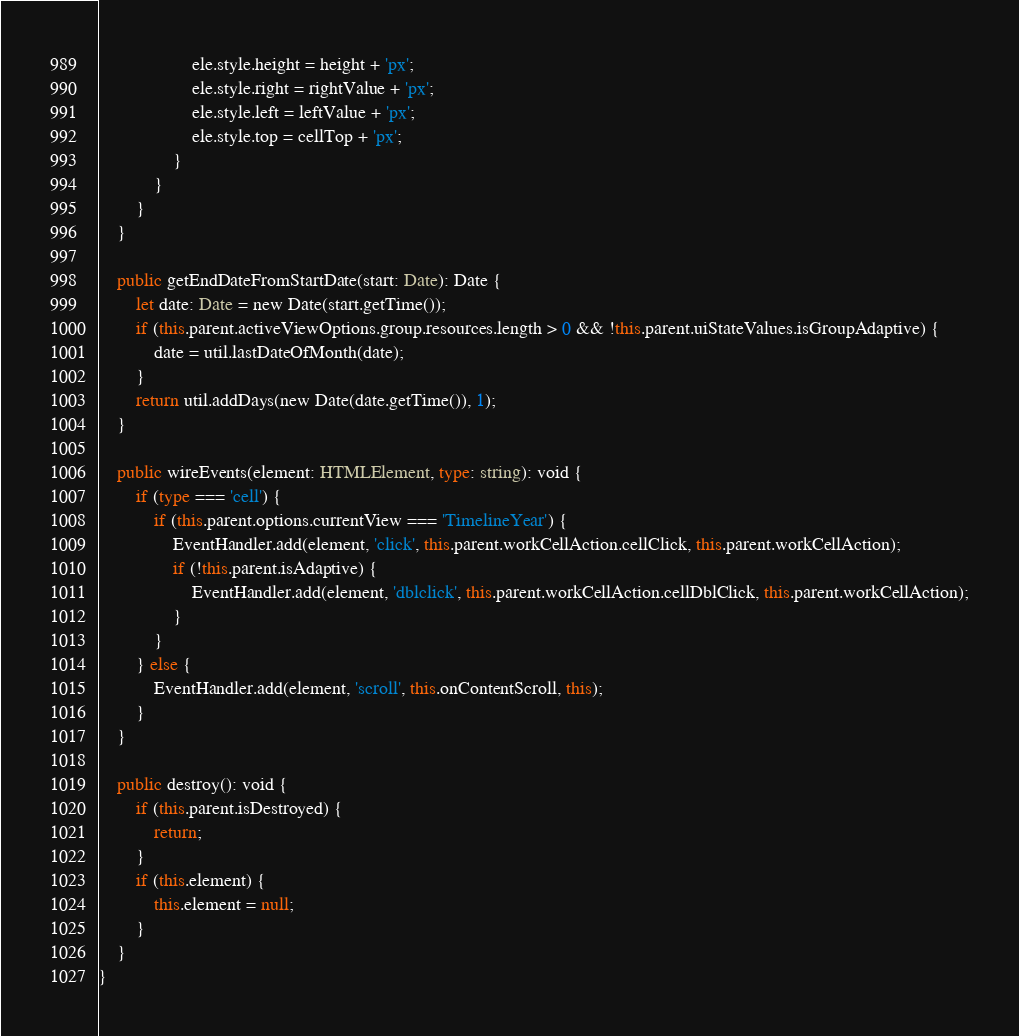Convert code to text. <code><loc_0><loc_0><loc_500><loc_500><_TypeScript_>                    ele.style.height = height + 'px';
                    ele.style.right = rightValue + 'px';
                    ele.style.left = leftValue + 'px';
                    ele.style.top = cellTop + 'px';
                }
            }
        }
    }

    public getEndDateFromStartDate(start: Date): Date {
        let date: Date = new Date(start.getTime());
        if (this.parent.activeViewOptions.group.resources.length > 0 && !this.parent.uiStateValues.isGroupAdaptive) {
            date = util.lastDateOfMonth(date);
        }
        return util.addDays(new Date(date.getTime()), 1);
    }

    public wireEvents(element: HTMLElement, type: string): void {
        if (type === 'cell') {
            if (this.parent.options.currentView === 'TimelineYear') {
                EventHandler.add(element, 'click', this.parent.workCellAction.cellClick, this.parent.workCellAction);
                if (!this.parent.isAdaptive) {
                    EventHandler.add(element, 'dblclick', this.parent.workCellAction.cellDblClick, this.parent.workCellAction);
                }
            }
        } else {
            EventHandler.add(element, 'scroll', this.onContentScroll, this);
        }
    }

    public destroy(): void {
        if (this.parent.isDestroyed) {
            return;
        }
        if (this.element) {
            this.element = null;
        }
    }
}
</code> 